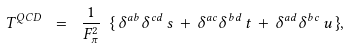<formula> <loc_0><loc_0><loc_500><loc_500>T ^ { Q C D } \ = \ \frac { 1 } { F _ { \pi } ^ { 2 } } \ \{ \, { \delta } ^ { a b } { \delta } ^ { c d } \, s \, + \, { \delta } ^ { a c } { \delta } ^ { b d } \, t \, + \, { \delta } ^ { a d } { \delta } ^ { b c } \, u \, \} ,</formula> 